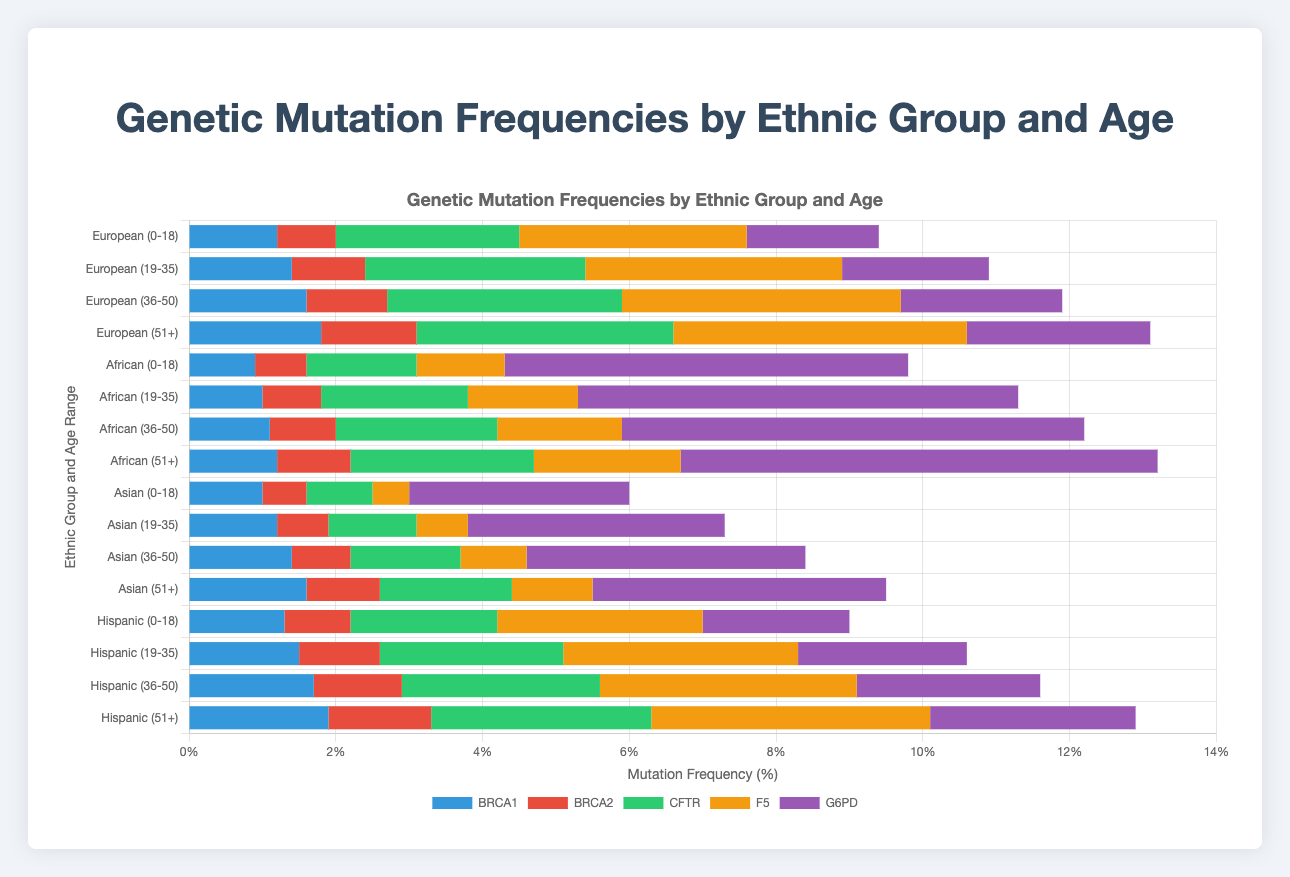Which ethnic group has the highest G6PD mutation frequency for the 0-18 age range? Look at the G6PD mutation bars for the 0-18 age range across all ethnic groups. The African group has a significantly higher G6PD mutation frequency compared to the others, with 5.5%.
Answer: African What is the total mutation frequency for BRCA1 across all age ranges for the European group? Sum the BRCA1 mutation frequencies for the European group across all age ranges: 1.2 (0-18) + 1.4 (19-35) + 1.6 (36-50) + 1.8 (51+). This results in a total of 6.0%.
Answer: 6.0% For the Asian group, which age range shows the highest CFTR mutation frequency? Compare the CFTR mutation frequencies for the Asian group across all age ranges: 0.9 (0-18), 1.2 (19-35), 1.5 (36-50), and 1.8 (51+). The 51+ age range has the highest value at 1.8%.
Answer: 51+ Which ethnic group shows the lowest mutation frequency for F5 in the 36-50 age range? Compare the F5 mutation frequencies for the 36-50 age range across all ethnic groups. Asian group has the lowest frequency, with 0.9%.
Answer: Asian How does the CFTR mutation frequency change from the 19-35 age range to the 51+ age range in the Hispanic group? Subtract the CFTR mutation frequency for the 19-35 age range (2.5%) from that of the 51+ age range (3.0%) in the Hispanic group, giving an increase of 0.5%.
Answer: It increases by 0.5% Which genetic mutation has the most significant increase in frequency when comparing the 0-18 to the 51+ age range for the African group? Compare the mutation frequencies across the age ranges within the African group. For BRCA1, it increases from 0.9 to 1.2; BRCA2 from 0.7 to 1.0; CFTR from 1.5 to 2.5; F5 from 1.2 to 2.0; G6PD from 5.5 to 6.5. The most significant increase is for CFTR (1.0%).
Answer: CFTR For the European group, compare the G6PD mutation frequency in the 36-50 and 51+ age ranges. Which age range has a higher frequency? Compare the G6PD mutation frequencies for the European group in the 36-50 age range (2.2%) and the 51+ age range (2.5%). The 51+ age range is higher.
Answer: 51+ Calculate the average mutation frequency for BRCA2 across all age ranges for the Hispanic group. Sum the BRCA2 mutation frequencies for Hispanic group across all age ranges: 0.9 (0-18) + 1.1 (19-35) + 1.2 (36-50) + 1.4 (51+), which totals to 4.6. Divide 4.6 by 4 (number of age ranges) to get the average: 4.6/4 = 1.15.
Answer: 1.15 Which mutation is depicted by the green color in the horizontal stacked bar chart? The green color represents the second dataset listed in the color function index sequence. According to the order in the provided JavaScript code, the dataset for CFTR mutation is colored green.
Answer: CFTR 